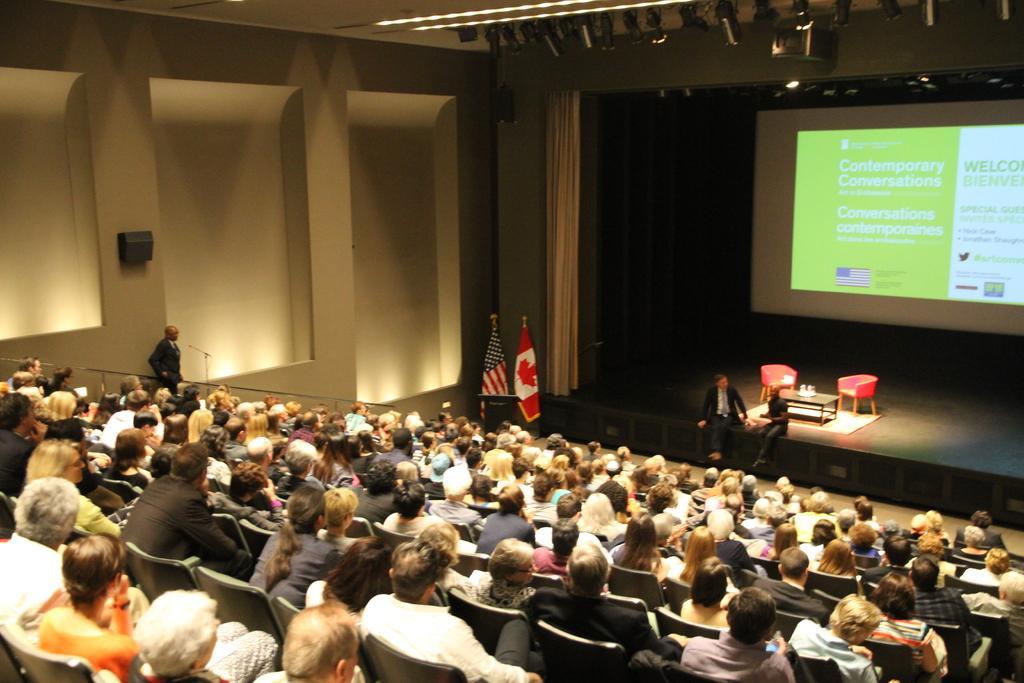How would you summarize this image in a sentence or two? In this picture we can see some people sitting on chairs, on the left side there is a person standing here, we can see screen in the background, there are two chairs and a table here, there are two flags and a curtain here. 